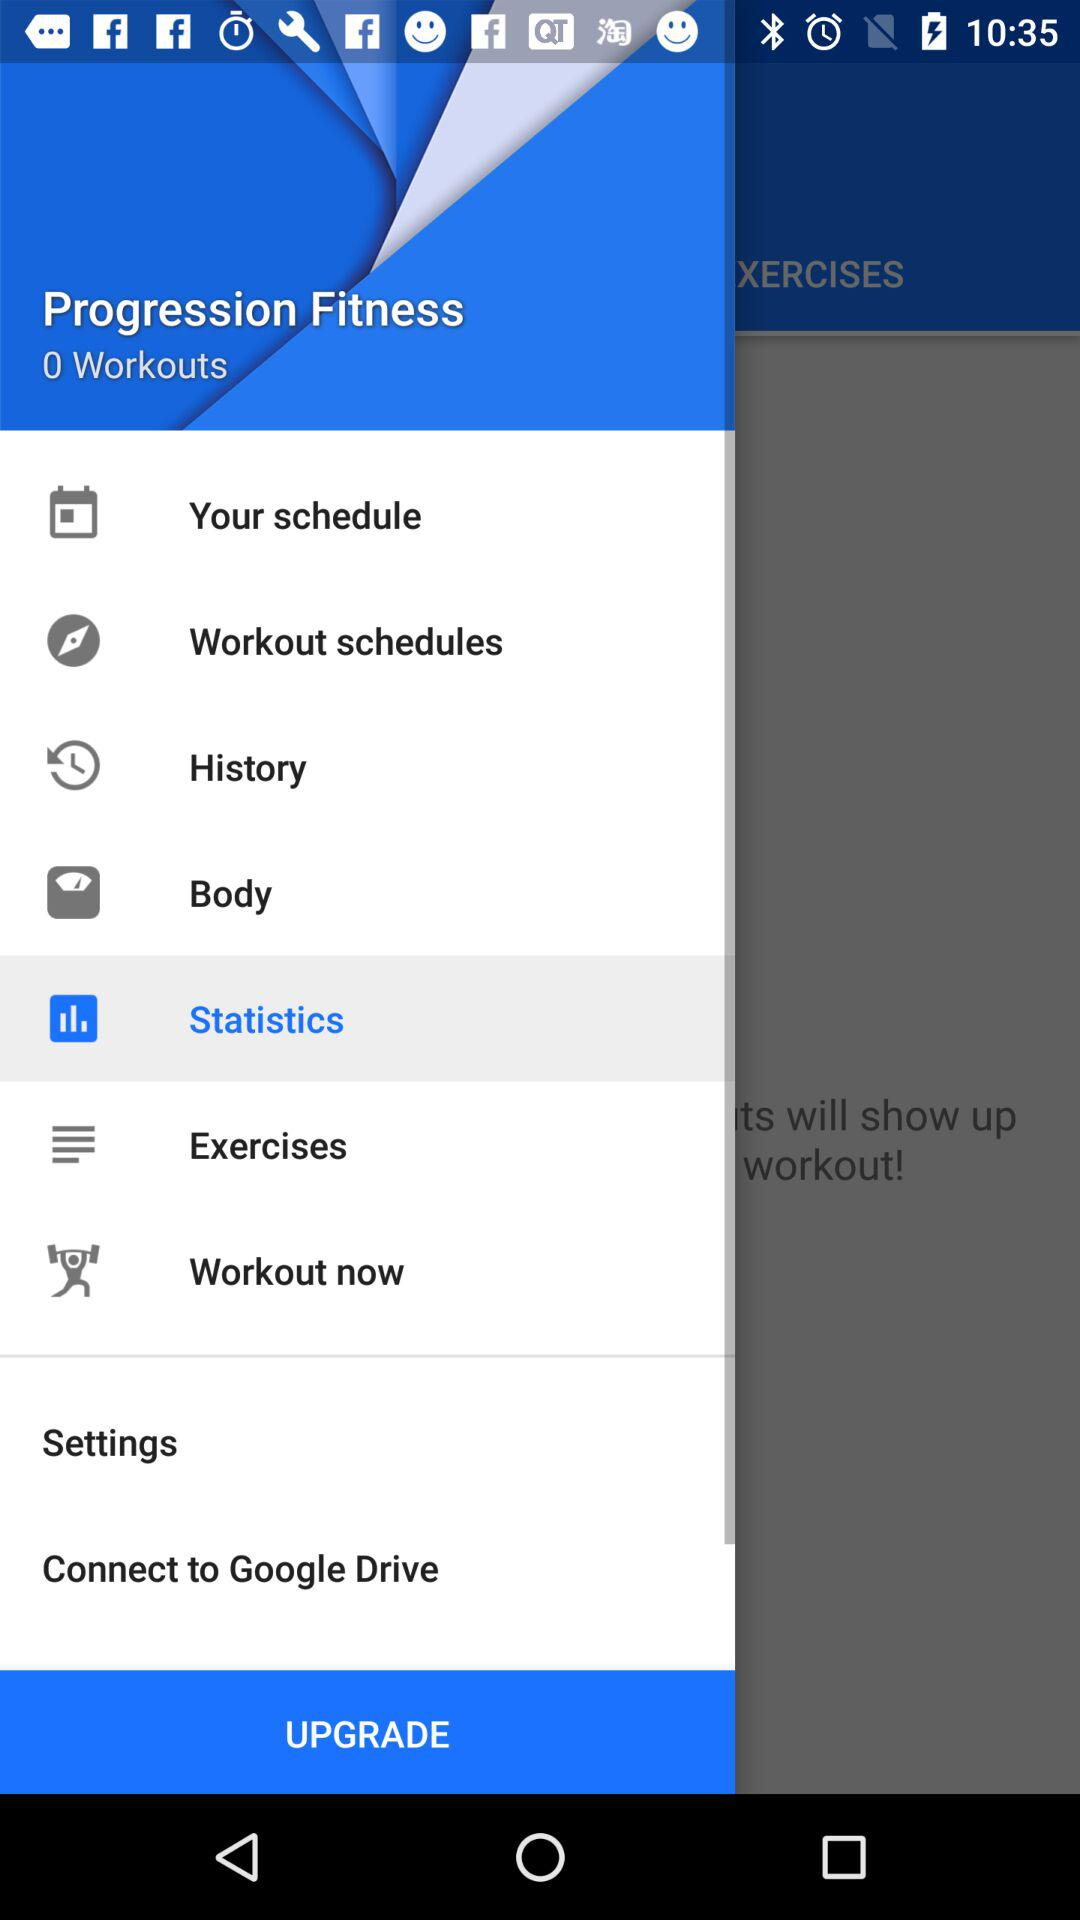How many workouts are there? There are 0 workouts. 